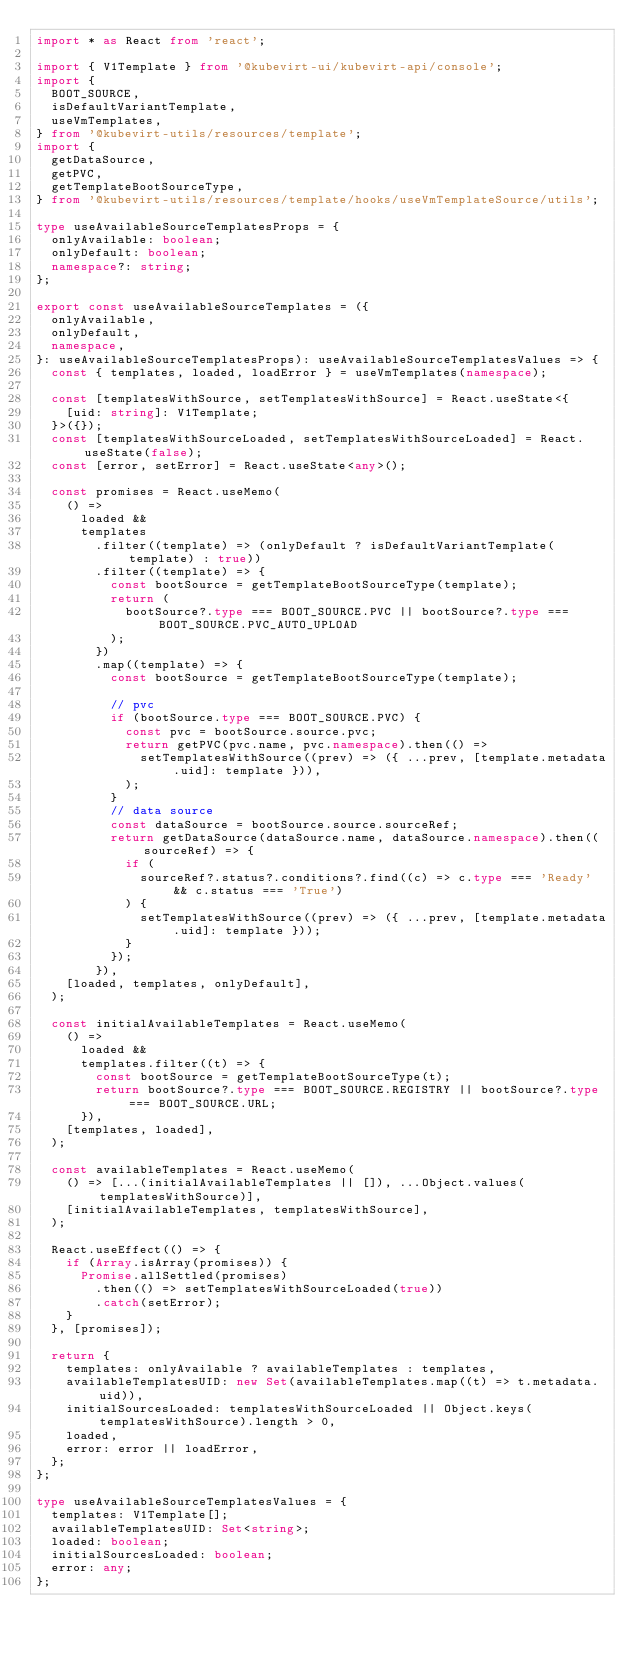Convert code to text. <code><loc_0><loc_0><loc_500><loc_500><_TypeScript_>import * as React from 'react';

import { V1Template } from '@kubevirt-ui/kubevirt-api/console';
import {
  BOOT_SOURCE,
  isDefaultVariantTemplate,
  useVmTemplates,
} from '@kubevirt-utils/resources/template';
import {
  getDataSource,
  getPVC,
  getTemplateBootSourceType,
} from '@kubevirt-utils/resources/template/hooks/useVmTemplateSource/utils';

type useAvailableSourceTemplatesProps = {
  onlyAvailable: boolean;
  onlyDefault: boolean;
  namespace?: string;
};

export const useAvailableSourceTemplates = ({
  onlyAvailable,
  onlyDefault,
  namespace,
}: useAvailableSourceTemplatesProps): useAvailableSourceTemplatesValues => {
  const { templates, loaded, loadError } = useVmTemplates(namespace);

  const [templatesWithSource, setTemplatesWithSource] = React.useState<{
    [uid: string]: V1Template;
  }>({});
  const [templatesWithSourceLoaded, setTemplatesWithSourceLoaded] = React.useState(false);
  const [error, setError] = React.useState<any>();

  const promises = React.useMemo(
    () =>
      loaded &&
      templates
        .filter((template) => (onlyDefault ? isDefaultVariantTemplate(template) : true))
        .filter((template) => {
          const bootSource = getTemplateBootSourceType(template);
          return (
            bootSource?.type === BOOT_SOURCE.PVC || bootSource?.type === BOOT_SOURCE.PVC_AUTO_UPLOAD
          );
        })
        .map((template) => {
          const bootSource = getTemplateBootSourceType(template);

          // pvc
          if (bootSource.type === BOOT_SOURCE.PVC) {
            const pvc = bootSource.source.pvc;
            return getPVC(pvc.name, pvc.namespace).then(() =>
              setTemplatesWithSource((prev) => ({ ...prev, [template.metadata.uid]: template })),
            );
          }
          // data source
          const dataSource = bootSource.source.sourceRef;
          return getDataSource(dataSource.name, dataSource.namespace).then((sourceRef) => {
            if (
              sourceRef?.status?.conditions?.find((c) => c.type === 'Ready' && c.status === 'True')
            ) {
              setTemplatesWithSource((prev) => ({ ...prev, [template.metadata.uid]: template }));
            }
          });
        }),
    [loaded, templates, onlyDefault],
  );

  const initialAvailableTemplates = React.useMemo(
    () =>
      loaded &&
      templates.filter((t) => {
        const bootSource = getTemplateBootSourceType(t);
        return bootSource?.type === BOOT_SOURCE.REGISTRY || bootSource?.type === BOOT_SOURCE.URL;
      }),
    [templates, loaded],
  );

  const availableTemplates = React.useMemo(
    () => [...(initialAvailableTemplates || []), ...Object.values(templatesWithSource)],
    [initialAvailableTemplates, templatesWithSource],
  );

  React.useEffect(() => {
    if (Array.isArray(promises)) {
      Promise.allSettled(promises)
        .then(() => setTemplatesWithSourceLoaded(true))
        .catch(setError);
    }
  }, [promises]);

  return {
    templates: onlyAvailable ? availableTemplates : templates,
    availableTemplatesUID: new Set(availableTemplates.map((t) => t.metadata.uid)),
    initialSourcesLoaded: templatesWithSourceLoaded || Object.keys(templatesWithSource).length > 0,
    loaded,
    error: error || loadError,
  };
};

type useAvailableSourceTemplatesValues = {
  templates: V1Template[];
  availableTemplatesUID: Set<string>;
  loaded: boolean;
  initialSourcesLoaded: boolean;
  error: any;
};
</code> 